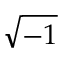Convert formula to latex. <formula><loc_0><loc_0><loc_500><loc_500>\sqrt { - 1 }</formula> 